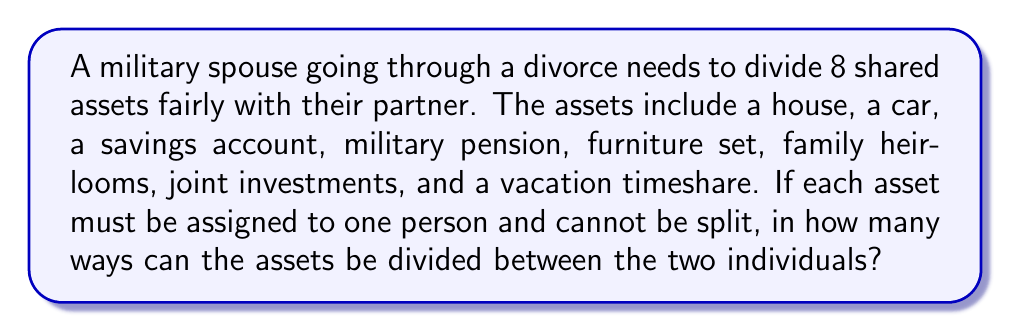Could you help me with this problem? Let's approach this step-by-step:

1) This is a combination problem. We need to choose which assets go to one person (the other person will get the remaining assets).

2) We can think of this as choosing a subset of assets for one person out of the total 8 assets.

3) The number of ways to choose $k$ items from $n$ items is given by the combination formula:

   $$\binom{n}{k} = \frac{n!}{k!(n-k)!}$$

4) In this case, we're choosing any number of assets from 0 to 8 for one person. The other person will get the remaining assets.

5) However, choosing 0 assets for one person is the same as choosing 8 for the other, choosing 1 is the same as choosing 7, and so on. To avoid double-counting, we only need to consider choices up to 4 assets.

6) So, the total number of ways is:

   $$\binom{8}{0} + \binom{8}{1} + \binom{8}{2} + \binom{8}{3} + \binom{8}{4}$$

7) Let's calculate each term:
   
   $\binom{8}{0} = 1$
   $\binom{8}{1} = 8$
   $\binom{8}{2} = 28$
   $\binom{8}{3} = 56$
   $\binom{8}{4} = 70$

8) Sum these up:

   $1 + 8 + 28 + 56 + 70 = 163$

Therefore, there are 163 ways to divide the assets.
Answer: 163 ways 